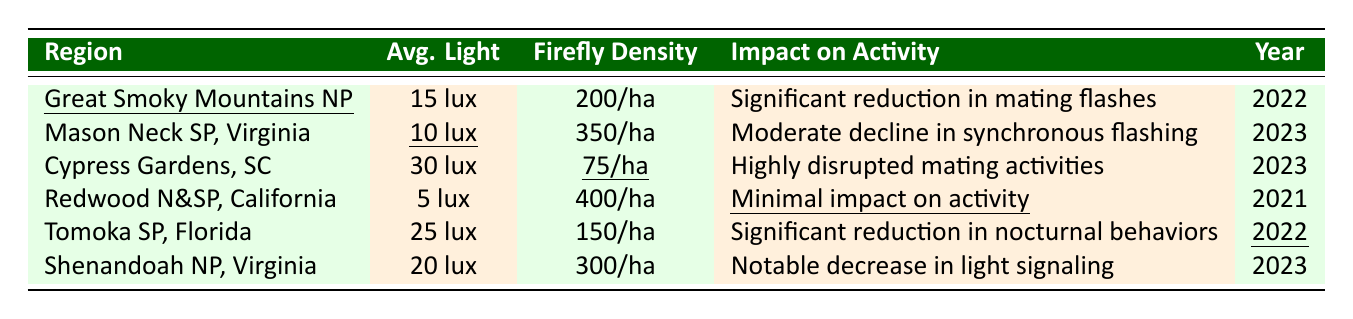What is the average light level in Mason Neck State Park? The table shows the average light level for Mason Neck State Park as 10 lux.
Answer: 10 lux Which region has the highest firefly population density? By looking at the firefly population density column, Redwood National and State Parks has the highest density with 400 fireflies/ha.
Answer: Redwood National and State Parks Is there a significant reduction in mating flashes observed in Great Smoky Mountains National Park? Yes, the table indicates a significant reduction in mating flashes observed in Great Smoky Mountains National Park.
Answer: Yes What is the difference in firefly population density between Cypress Gardens and Tomoka State Park? The firefly density in Cypress Gardens is 75 fireflies/ha, and in Tomoka State Park, it is 150 fireflies/ha. The difference is 150 - 75 = 75 fireflies/ha.
Answer: 75 fireflies/ha How many regions reported moderate declines in firefly activity? The table lists two regions: Mason Neck State Park (moderate decline in synchronous flashing) and Tomoka State Park (significant reduction in nocturnal behaviors). So, only one region reported moderate decline based on the provided descriptions.
Answer: 1 region What is the relationship between average light level and firefly population density in areas studied? The table shows that as the average light level increases, firefly population density decreases in some regions, like Cypress Gardens compared to Redwood National and State Parks. There are exceptions, indicating a complex relationship rather than a direct correlation.
Answer: Complex relationship In which year was the least light pollution observed, according to the table? The least light pollution is seen in Redwood National and State Parks, reported with an average light level of 5 lux in 2021.
Answer: 2021 Which park had the most significant impact on firefly activity, based on the summary? Cypress Gardens had the most significant impact, recording highly disrupted mating activities at an average light level of 30 lux.
Answer: Cypress Gardens If averages for the years are taken into account, which year saw a higher average light pollution level, 2022 or 2023? The average light levels for 2022 are (15 + 25) / 2 = 20 lux and for 2023 are (10 + 20 + 30) / 3 = 20 lux. Both years have an equal average, so there's no higher average.
Answer: Neither, they are equal What specific impact on activity was noted for Shenandoah National Park? The impact noted for Shenandoah National Park was a notable decrease in light signaling patterns according to the table.
Answer: Notable decrease in light signaling patterns 